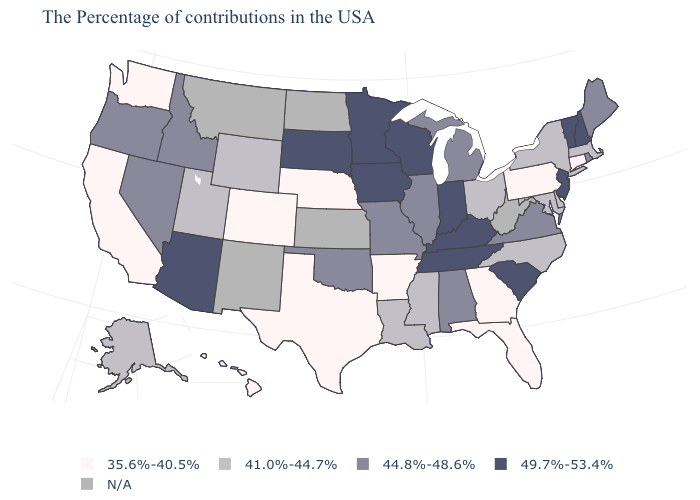Name the states that have a value in the range 35.6%-40.5%?
Short answer required. Connecticut, Pennsylvania, Florida, Georgia, Arkansas, Nebraska, Texas, Colorado, California, Washington, Hawaii. What is the value of Michigan?
Short answer required. 44.8%-48.6%. Does Pennsylvania have the lowest value in the USA?
Keep it brief. Yes. What is the highest value in states that border North Carolina?
Short answer required. 49.7%-53.4%. Name the states that have a value in the range 41.0%-44.7%?
Give a very brief answer. Massachusetts, New York, Delaware, Maryland, North Carolina, Ohio, Mississippi, Louisiana, Wyoming, Utah, Alaska. Name the states that have a value in the range 41.0%-44.7%?
Keep it brief. Massachusetts, New York, Delaware, Maryland, North Carolina, Ohio, Mississippi, Louisiana, Wyoming, Utah, Alaska. What is the highest value in the South ?
Quick response, please. 49.7%-53.4%. Name the states that have a value in the range 49.7%-53.4%?
Concise answer only. New Hampshire, Vermont, New Jersey, South Carolina, Kentucky, Indiana, Tennessee, Wisconsin, Minnesota, Iowa, South Dakota, Arizona. Does the map have missing data?
Short answer required. Yes. How many symbols are there in the legend?
Quick response, please. 5. Name the states that have a value in the range 35.6%-40.5%?
Answer briefly. Connecticut, Pennsylvania, Florida, Georgia, Arkansas, Nebraska, Texas, Colorado, California, Washington, Hawaii. Name the states that have a value in the range 44.8%-48.6%?
Be succinct. Maine, Rhode Island, Virginia, Michigan, Alabama, Illinois, Missouri, Oklahoma, Idaho, Nevada, Oregon. Name the states that have a value in the range N/A?
Answer briefly. West Virginia, Kansas, North Dakota, New Mexico, Montana. Name the states that have a value in the range N/A?
Give a very brief answer. West Virginia, Kansas, North Dakota, New Mexico, Montana. Name the states that have a value in the range 44.8%-48.6%?
Keep it brief. Maine, Rhode Island, Virginia, Michigan, Alabama, Illinois, Missouri, Oklahoma, Idaho, Nevada, Oregon. 